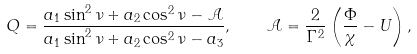<formula> <loc_0><loc_0><loc_500><loc_500>Q = \frac { a _ { 1 } \sin ^ { 2 } \nu + a _ { 2 } \cos ^ { 2 } \nu - \mathcal { A } } { a _ { 1 } \sin ^ { 2 } \nu + a _ { 2 } \cos ^ { 2 } \nu - a _ { 3 } } , \quad \mathcal { A } = \frac { 2 } { \Gamma ^ { 2 } } \left ( \frac { \Phi } { \chi } - U \right ) ,</formula> 